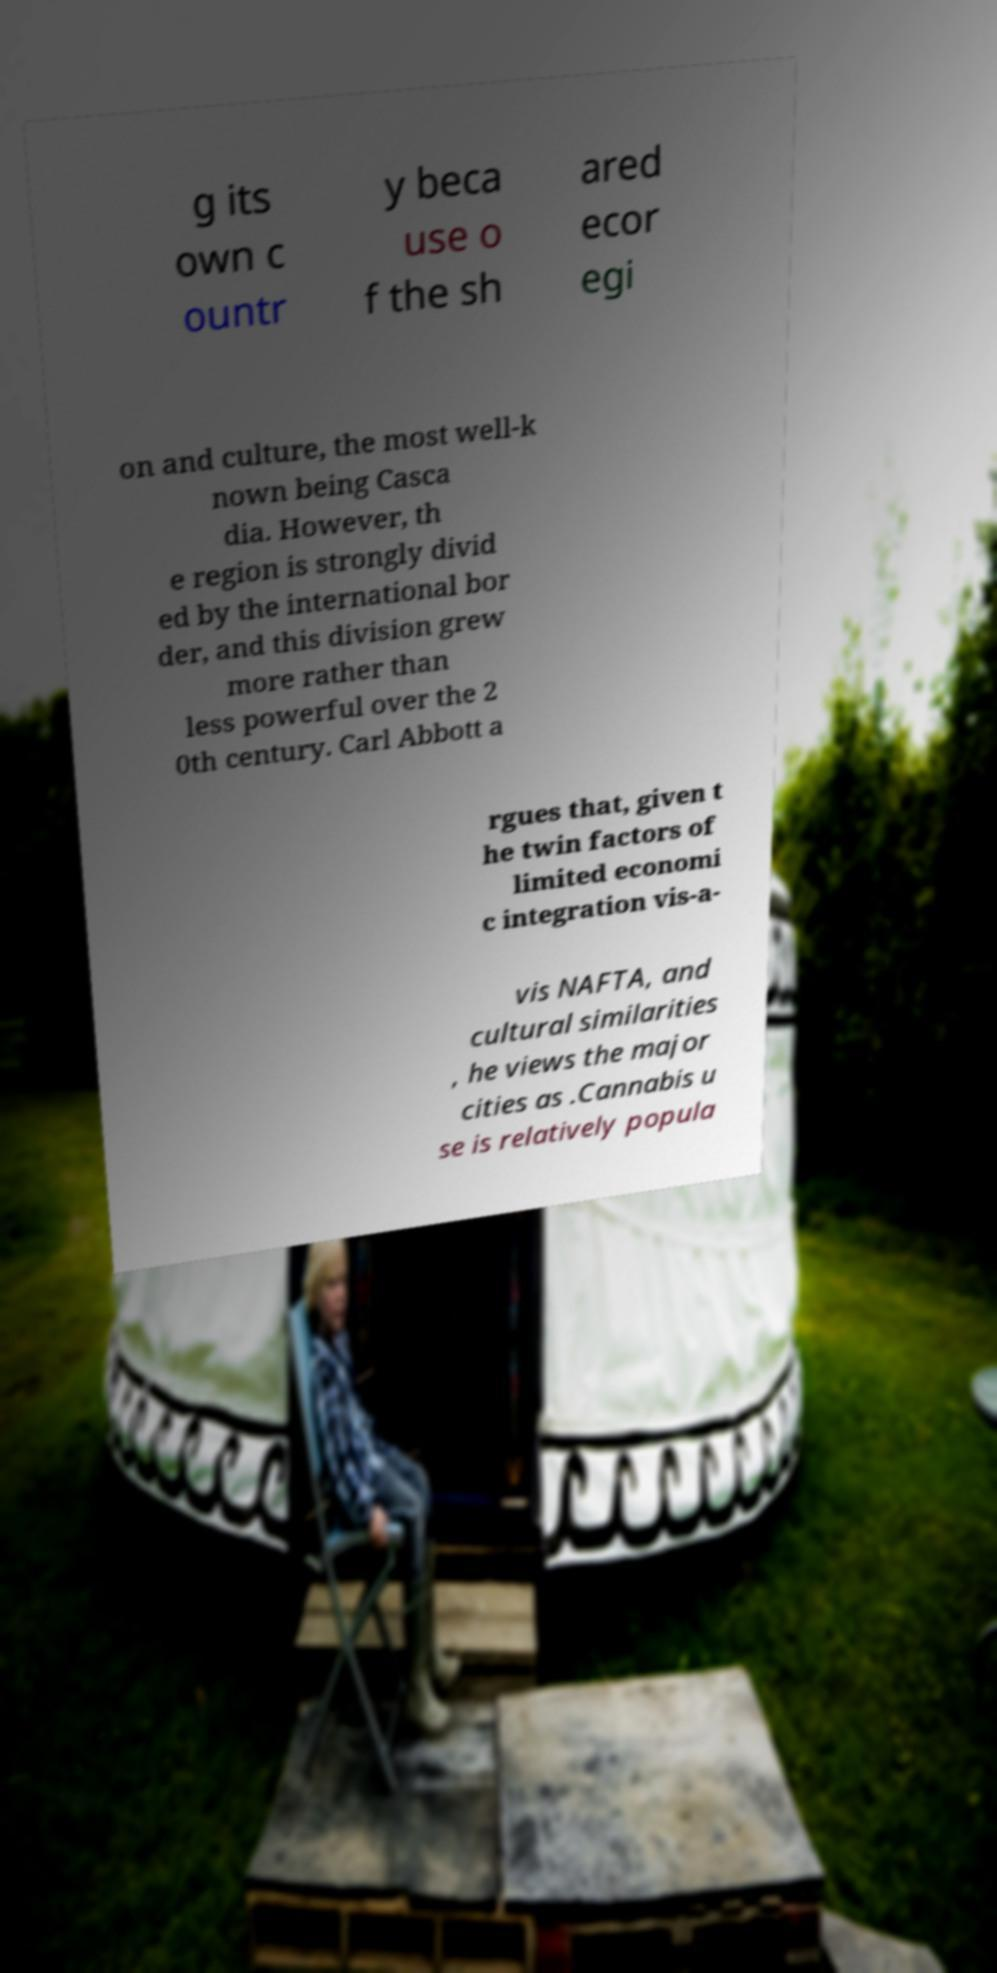Can you read and provide the text displayed in the image?This photo seems to have some interesting text. Can you extract and type it out for me? g its own c ountr y beca use o f the sh ared ecor egi on and culture, the most well-k nown being Casca dia. However, th e region is strongly divid ed by the international bor der, and this division grew more rather than less powerful over the 2 0th century. Carl Abbott a rgues that, given t he twin factors of limited economi c integration vis-a- vis NAFTA, and cultural similarities , he views the major cities as .Cannabis u se is relatively popula 